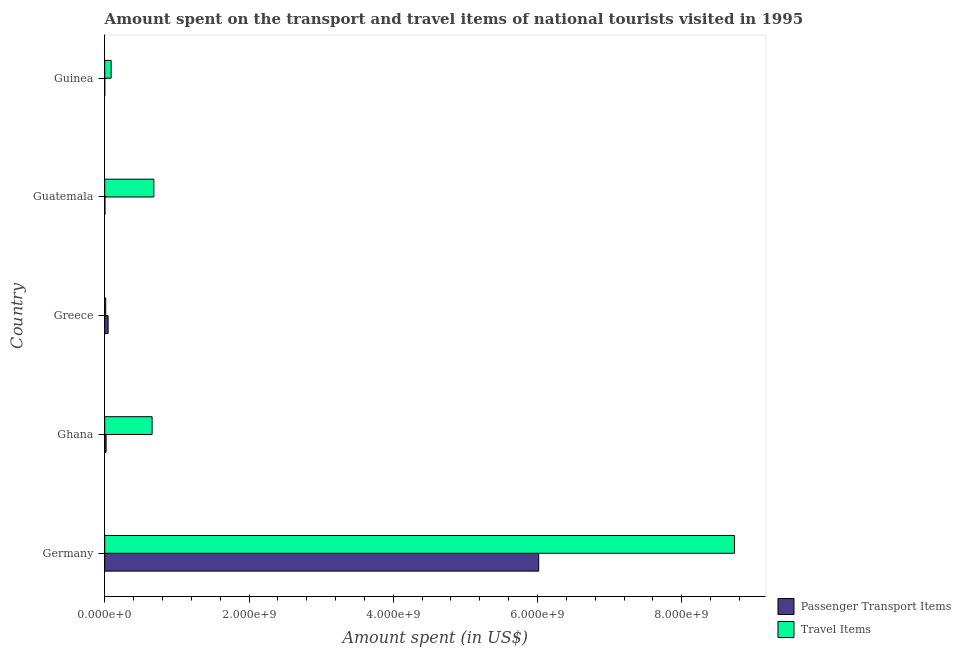How many different coloured bars are there?
Provide a short and direct response. 2. How many groups of bars are there?
Keep it short and to the point. 5. What is the label of the 1st group of bars from the top?
Make the answer very short. Guinea. What is the amount spent on passenger transport items in Guatemala?
Your answer should be very brief. 3.00e+06. Across all countries, what is the maximum amount spent on passenger transport items?
Offer a terse response. 6.02e+09. Across all countries, what is the minimum amount spent on passenger transport items?
Ensure brevity in your answer.  1.10e+04. In which country was the amount spent on passenger transport items minimum?
Your answer should be compact. Guinea. What is the total amount spent on passenger transport items in the graph?
Make the answer very short. 6.09e+09. What is the difference between the amount spent in travel items in Germany and that in Guatemala?
Ensure brevity in your answer.  8.05e+09. What is the difference between the amount spent in travel items in Ghana and the amount spent on passenger transport items in Greece?
Your answer should be compact. 6.10e+08. What is the average amount spent on passenger transport items per country?
Keep it short and to the point. 1.22e+09. What is the difference between the amount spent in travel items and amount spent on passenger transport items in Greece?
Provide a short and direct response. -3.30e+07. What is the ratio of the amount spent on passenger transport items in Greece to that in Guinea?
Your response must be concise. 4272.73. What is the difference between the highest and the second highest amount spent on passenger transport items?
Offer a terse response. 5.97e+09. What is the difference between the highest and the lowest amount spent in travel items?
Provide a short and direct response. 8.72e+09. What does the 2nd bar from the top in Ghana represents?
Ensure brevity in your answer.  Passenger Transport Items. What does the 2nd bar from the bottom in Germany represents?
Offer a terse response. Travel Items. Are all the bars in the graph horizontal?
Ensure brevity in your answer.  Yes. How many countries are there in the graph?
Offer a terse response. 5. What is the difference between two consecutive major ticks on the X-axis?
Your answer should be compact. 2.00e+09. Does the graph contain any zero values?
Ensure brevity in your answer.  No. Where does the legend appear in the graph?
Give a very brief answer. Bottom right. How many legend labels are there?
Offer a terse response. 2. What is the title of the graph?
Ensure brevity in your answer.  Amount spent on the transport and travel items of national tourists visited in 1995. What is the label or title of the X-axis?
Your answer should be compact. Amount spent (in US$). What is the Amount spent (in US$) in Passenger Transport Items in Germany?
Your response must be concise. 6.02e+09. What is the Amount spent (in US$) in Travel Items in Germany?
Keep it short and to the point. 8.73e+09. What is the Amount spent (in US$) of Passenger Transport Items in Ghana?
Provide a succinct answer. 1.90e+07. What is the Amount spent (in US$) of Travel Items in Ghana?
Keep it short and to the point. 6.57e+08. What is the Amount spent (in US$) of Passenger Transport Items in Greece?
Provide a succinct answer. 4.70e+07. What is the Amount spent (in US$) in Travel Items in Greece?
Offer a very short reply. 1.40e+07. What is the Amount spent (in US$) of Passenger Transport Items in Guatemala?
Make the answer very short. 3.00e+06. What is the Amount spent (in US$) of Travel Items in Guatemala?
Make the answer very short. 6.81e+08. What is the Amount spent (in US$) of Passenger Transport Items in Guinea?
Offer a terse response. 1.10e+04. What is the Amount spent (in US$) of Travel Items in Guinea?
Offer a very short reply. 8.90e+07. Across all countries, what is the maximum Amount spent (in US$) of Passenger Transport Items?
Offer a very short reply. 6.02e+09. Across all countries, what is the maximum Amount spent (in US$) in Travel Items?
Offer a very short reply. 8.73e+09. Across all countries, what is the minimum Amount spent (in US$) in Passenger Transport Items?
Keep it short and to the point. 1.10e+04. Across all countries, what is the minimum Amount spent (in US$) of Travel Items?
Your answer should be very brief. 1.40e+07. What is the total Amount spent (in US$) in Passenger Transport Items in the graph?
Your answer should be very brief. 6.09e+09. What is the total Amount spent (in US$) in Travel Items in the graph?
Provide a short and direct response. 1.02e+1. What is the difference between the Amount spent (in US$) of Passenger Transport Items in Germany and that in Ghana?
Your answer should be very brief. 6.00e+09. What is the difference between the Amount spent (in US$) in Travel Items in Germany and that in Ghana?
Make the answer very short. 8.07e+09. What is the difference between the Amount spent (in US$) of Passenger Transport Items in Germany and that in Greece?
Provide a succinct answer. 5.97e+09. What is the difference between the Amount spent (in US$) of Travel Items in Germany and that in Greece?
Your answer should be very brief. 8.72e+09. What is the difference between the Amount spent (in US$) of Passenger Transport Items in Germany and that in Guatemala?
Provide a short and direct response. 6.01e+09. What is the difference between the Amount spent (in US$) of Travel Items in Germany and that in Guatemala?
Offer a very short reply. 8.05e+09. What is the difference between the Amount spent (in US$) in Passenger Transport Items in Germany and that in Guinea?
Provide a succinct answer. 6.02e+09. What is the difference between the Amount spent (in US$) of Travel Items in Germany and that in Guinea?
Give a very brief answer. 8.64e+09. What is the difference between the Amount spent (in US$) of Passenger Transport Items in Ghana and that in Greece?
Provide a short and direct response. -2.80e+07. What is the difference between the Amount spent (in US$) in Travel Items in Ghana and that in Greece?
Provide a succinct answer. 6.43e+08. What is the difference between the Amount spent (in US$) in Passenger Transport Items in Ghana and that in Guatemala?
Provide a short and direct response. 1.60e+07. What is the difference between the Amount spent (in US$) in Travel Items in Ghana and that in Guatemala?
Provide a succinct answer. -2.40e+07. What is the difference between the Amount spent (in US$) of Passenger Transport Items in Ghana and that in Guinea?
Keep it short and to the point. 1.90e+07. What is the difference between the Amount spent (in US$) in Travel Items in Ghana and that in Guinea?
Keep it short and to the point. 5.68e+08. What is the difference between the Amount spent (in US$) of Passenger Transport Items in Greece and that in Guatemala?
Provide a short and direct response. 4.40e+07. What is the difference between the Amount spent (in US$) of Travel Items in Greece and that in Guatemala?
Make the answer very short. -6.67e+08. What is the difference between the Amount spent (in US$) in Passenger Transport Items in Greece and that in Guinea?
Keep it short and to the point. 4.70e+07. What is the difference between the Amount spent (in US$) of Travel Items in Greece and that in Guinea?
Ensure brevity in your answer.  -7.50e+07. What is the difference between the Amount spent (in US$) in Passenger Transport Items in Guatemala and that in Guinea?
Provide a short and direct response. 2.99e+06. What is the difference between the Amount spent (in US$) in Travel Items in Guatemala and that in Guinea?
Your answer should be very brief. 5.92e+08. What is the difference between the Amount spent (in US$) in Passenger Transport Items in Germany and the Amount spent (in US$) in Travel Items in Ghana?
Give a very brief answer. 5.36e+09. What is the difference between the Amount spent (in US$) in Passenger Transport Items in Germany and the Amount spent (in US$) in Travel Items in Greece?
Your answer should be very brief. 6.00e+09. What is the difference between the Amount spent (in US$) in Passenger Transport Items in Germany and the Amount spent (in US$) in Travel Items in Guatemala?
Ensure brevity in your answer.  5.34e+09. What is the difference between the Amount spent (in US$) of Passenger Transport Items in Germany and the Amount spent (in US$) of Travel Items in Guinea?
Your answer should be very brief. 5.93e+09. What is the difference between the Amount spent (in US$) in Passenger Transport Items in Ghana and the Amount spent (in US$) in Travel Items in Greece?
Provide a succinct answer. 5.00e+06. What is the difference between the Amount spent (in US$) of Passenger Transport Items in Ghana and the Amount spent (in US$) of Travel Items in Guatemala?
Offer a very short reply. -6.62e+08. What is the difference between the Amount spent (in US$) of Passenger Transport Items in Ghana and the Amount spent (in US$) of Travel Items in Guinea?
Offer a terse response. -7.00e+07. What is the difference between the Amount spent (in US$) of Passenger Transport Items in Greece and the Amount spent (in US$) of Travel Items in Guatemala?
Offer a very short reply. -6.34e+08. What is the difference between the Amount spent (in US$) in Passenger Transport Items in Greece and the Amount spent (in US$) in Travel Items in Guinea?
Ensure brevity in your answer.  -4.20e+07. What is the difference between the Amount spent (in US$) in Passenger Transport Items in Guatemala and the Amount spent (in US$) in Travel Items in Guinea?
Provide a succinct answer. -8.60e+07. What is the average Amount spent (in US$) in Passenger Transport Items per country?
Give a very brief answer. 1.22e+09. What is the average Amount spent (in US$) in Travel Items per country?
Keep it short and to the point. 2.03e+09. What is the difference between the Amount spent (in US$) in Passenger Transport Items and Amount spent (in US$) in Travel Items in Germany?
Your response must be concise. -2.71e+09. What is the difference between the Amount spent (in US$) of Passenger Transport Items and Amount spent (in US$) of Travel Items in Ghana?
Offer a terse response. -6.38e+08. What is the difference between the Amount spent (in US$) in Passenger Transport Items and Amount spent (in US$) in Travel Items in Greece?
Offer a very short reply. 3.30e+07. What is the difference between the Amount spent (in US$) in Passenger Transport Items and Amount spent (in US$) in Travel Items in Guatemala?
Provide a short and direct response. -6.78e+08. What is the difference between the Amount spent (in US$) of Passenger Transport Items and Amount spent (in US$) of Travel Items in Guinea?
Give a very brief answer. -8.90e+07. What is the ratio of the Amount spent (in US$) of Passenger Transport Items in Germany to that in Ghana?
Keep it short and to the point. 316.63. What is the ratio of the Amount spent (in US$) of Travel Items in Germany to that in Ghana?
Your answer should be compact. 13.29. What is the ratio of the Amount spent (in US$) in Passenger Transport Items in Germany to that in Greece?
Offer a very short reply. 128. What is the ratio of the Amount spent (in US$) of Travel Items in Germany to that in Greece?
Your response must be concise. 623.57. What is the ratio of the Amount spent (in US$) of Passenger Transport Items in Germany to that in Guatemala?
Your answer should be compact. 2005.33. What is the ratio of the Amount spent (in US$) of Travel Items in Germany to that in Guatemala?
Offer a terse response. 12.82. What is the ratio of the Amount spent (in US$) of Passenger Transport Items in Germany to that in Guinea?
Offer a terse response. 5.47e+05. What is the ratio of the Amount spent (in US$) in Travel Items in Germany to that in Guinea?
Offer a very short reply. 98.09. What is the ratio of the Amount spent (in US$) of Passenger Transport Items in Ghana to that in Greece?
Ensure brevity in your answer.  0.4. What is the ratio of the Amount spent (in US$) in Travel Items in Ghana to that in Greece?
Your answer should be compact. 46.93. What is the ratio of the Amount spent (in US$) of Passenger Transport Items in Ghana to that in Guatemala?
Provide a succinct answer. 6.33. What is the ratio of the Amount spent (in US$) of Travel Items in Ghana to that in Guatemala?
Your answer should be very brief. 0.96. What is the ratio of the Amount spent (in US$) in Passenger Transport Items in Ghana to that in Guinea?
Offer a very short reply. 1727.27. What is the ratio of the Amount spent (in US$) in Travel Items in Ghana to that in Guinea?
Offer a terse response. 7.38. What is the ratio of the Amount spent (in US$) of Passenger Transport Items in Greece to that in Guatemala?
Give a very brief answer. 15.67. What is the ratio of the Amount spent (in US$) in Travel Items in Greece to that in Guatemala?
Make the answer very short. 0.02. What is the ratio of the Amount spent (in US$) of Passenger Transport Items in Greece to that in Guinea?
Your answer should be compact. 4272.73. What is the ratio of the Amount spent (in US$) in Travel Items in Greece to that in Guinea?
Ensure brevity in your answer.  0.16. What is the ratio of the Amount spent (in US$) in Passenger Transport Items in Guatemala to that in Guinea?
Your answer should be compact. 272.73. What is the ratio of the Amount spent (in US$) of Travel Items in Guatemala to that in Guinea?
Keep it short and to the point. 7.65. What is the difference between the highest and the second highest Amount spent (in US$) in Passenger Transport Items?
Offer a very short reply. 5.97e+09. What is the difference between the highest and the second highest Amount spent (in US$) of Travel Items?
Ensure brevity in your answer.  8.05e+09. What is the difference between the highest and the lowest Amount spent (in US$) in Passenger Transport Items?
Your response must be concise. 6.02e+09. What is the difference between the highest and the lowest Amount spent (in US$) of Travel Items?
Your response must be concise. 8.72e+09. 